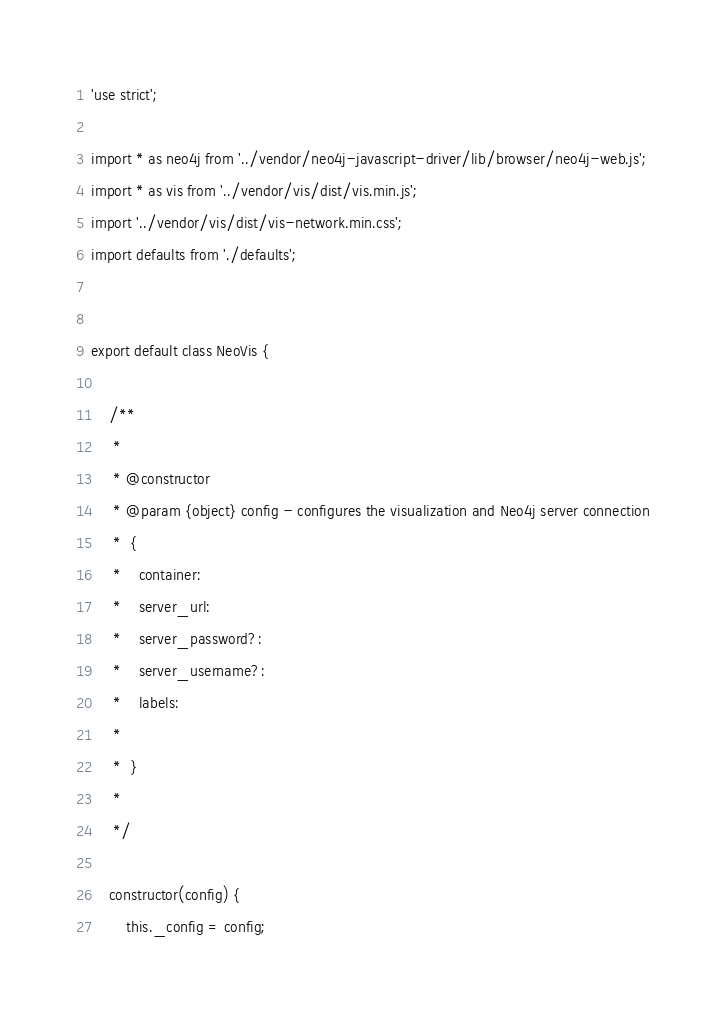Convert code to text. <code><loc_0><loc_0><loc_500><loc_500><_JavaScript_>'use strict';

import * as neo4j from '../vendor/neo4j-javascript-driver/lib/browser/neo4j-web.js';
import * as vis from '../vendor/vis/dist/vis.min.js';
import '../vendor/vis/dist/vis-network.min.css';
import defaults from './defaults';


export default class NeoVis {

    /**
     *
     * @constructor
     * @param {object} config - configures the visualization and Neo4j server connection
     *  {
     *    container:
     *    server_url:
     *    server_password?:
     *    server_username?:
     *    labels:
     *
     *  }
     *
     */

    constructor(config) {
        this._config = config;</code> 